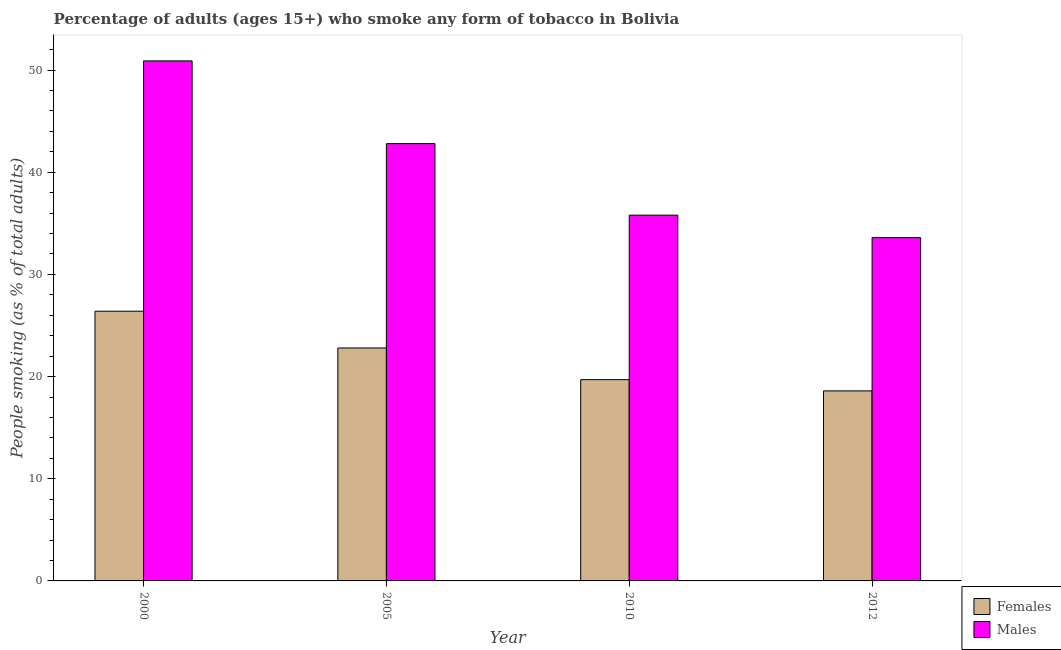How many groups of bars are there?
Your response must be concise. 4. Are the number of bars per tick equal to the number of legend labels?
Make the answer very short. Yes. In how many cases, is the number of bars for a given year not equal to the number of legend labels?
Provide a short and direct response. 0. What is the percentage of males who smoke in 2005?
Offer a very short reply. 42.8. Across all years, what is the maximum percentage of females who smoke?
Provide a short and direct response. 26.4. Across all years, what is the minimum percentage of males who smoke?
Offer a very short reply. 33.6. In which year was the percentage of males who smoke maximum?
Provide a succinct answer. 2000. In which year was the percentage of males who smoke minimum?
Your response must be concise. 2012. What is the total percentage of females who smoke in the graph?
Provide a succinct answer. 87.5. What is the difference between the percentage of males who smoke in 2010 and the percentage of females who smoke in 2000?
Provide a short and direct response. -15.1. What is the average percentage of males who smoke per year?
Offer a terse response. 40.77. What is the ratio of the percentage of females who smoke in 2005 to that in 2010?
Give a very brief answer. 1.16. Is the difference between the percentage of females who smoke in 2005 and 2010 greater than the difference between the percentage of males who smoke in 2005 and 2010?
Your answer should be compact. No. What is the difference between the highest and the second highest percentage of females who smoke?
Ensure brevity in your answer.  3.6. What is the difference between the highest and the lowest percentage of females who smoke?
Provide a short and direct response. 7.8. Is the sum of the percentage of females who smoke in 2000 and 2012 greater than the maximum percentage of males who smoke across all years?
Keep it short and to the point. Yes. What does the 2nd bar from the left in 2000 represents?
Your answer should be very brief. Males. What does the 2nd bar from the right in 2000 represents?
Make the answer very short. Females. How many bars are there?
Provide a succinct answer. 8. Are all the bars in the graph horizontal?
Give a very brief answer. No. Are the values on the major ticks of Y-axis written in scientific E-notation?
Make the answer very short. No. Does the graph contain any zero values?
Ensure brevity in your answer.  No. Where does the legend appear in the graph?
Keep it short and to the point. Bottom right. How many legend labels are there?
Keep it short and to the point. 2. How are the legend labels stacked?
Provide a short and direct response. Vertical. What is the title of the graph?
Provide a succinct answer. Percentage of adults (ages 15+) who smoke any form of tobacco in Bolivia. Does "Girls" appear as one of the legend labels in the graph?
Your answer should be compact. No. What is the label or title of the Y-axis?
Offer a terse response. People smoking (as % of total adults). What is the People smoking (as % of total adults) of Females in 2000?
Keep it short and to the point. 26.4. What is the People smoking (as % of total adults) in Males in 2000?
Your response must be concise. 50.9. What is the People smoking (as % of total adults) in Females in 2005?
Provide a short and direct response. 22.8. What is the People smoking (as % of total adults) in Males in 2005?
Provide a short and direct response. 42.8. What is the People smoking (as % of total adults) in Females in 2010?
Your answer should be very brief. 19.7. What is the People smoking (as % of total adults) of Males in 2010?
Offer a terse response. 35.8. What is the People smoking (as % of total adults) in Females in 2012?
Keep it short and to the point. 18.6. What is the People smoking (as % of total adults) in Males in 2012?
Offer a very short reply. 33.6. Across all years, what is the maximum People smoking (as % of total adults) in Females?
Your answer should be compact. 26.4. Across all years, what is the maximum People smoking (as % of total adults) in Males?
Ensure brevity in your answer.  50.9. Across all years, what is the minimum People smoking (as % of total adults) in Males?
Provide a succinct answer. 33.6. What is the total People smoking (as % of total adults) of Females in the graph?
Your response must be concise. 87.5. What is the total People smoking (as % of total adults) of Males in the graph?
Ensure brevity in your answer.  163.1. What is the difference between the People smoking (as % of total adults) of Females in 2000 and that in 2005?
Offer a very short reply. 3.6. What is the difference between the People smoking (as % of total adults) of Males in 2000 and that in 2005?
Provide a succinct answer. 8.1. What is the difference between the People smoking (as % of total adults) of Males in 2000 and that in 2010?
Keep it short and to the point. 15.1. What is the difference between the People smoking (as % of total adults) of Females in 2000 and the People smoking (as % of total adults) of Males in 2005?
Your response must be concise. -16.4. What is the average People smoking (as % of total adults) of Females per year?
Make the answer very short. 21.88. What is the average People smoking (as % of total adults) in Males per year?
Provide a short and direct response. 40.77. In the year 2000, what is the difference between the People smoking (as % of total adults) of Females and People smoking (as % of total adults) of Males?
Provide a succinct answer. -24.5. In the year 2005, what is the difference between the People smoking (as % of total adults) in Females and People smoking (as % of total adults) in Males?
Your answer should be compact. -20. In the year 2010, what is the difference between the People smoking (as % of total adults) of Females and People smoking (as % of total adults) of Males?
Provide a short and direct response. -16.1. In the year 2012, what is the difference between the People smoking (as % of total adults) of Females and People smoking (as % of total adults) of Males?
Your response must be concise. -15. What is the ratio of the People smoking (as % of total adults) in Females in 2000 to that in 2005?
Provide a succinct answer. 1.16. What is the ratio of the People smoking (as % of total adults) in Males in 2000 to that in 2005?
Offer a terse response. 1.19. What is the ratio of the People smoking (as % of total adults) of Females in 2000 to that in 2010?
Provide a succinct answer. 1.34. What is the ratio of the People smoking (as % of total adults) in Males in 2000 to that in 2010?
Give a very brief answer. 1.42. What is the ratio of the People smoking (as % of total adults) of Females in 2000 to that in 2012?
Your response must be concise. 1.42. What is the ratio of the People smoking (as % of total adults) in Males in 2000 to that in 2012?
Your answer should be compact. 1.51. What is the ratio of the People smoking (as % of total adults) in Females in 2005 to that in 2010?
Your response must be concise. 1.16. What is the ratio of the People smoking (as % of total adults) of Males in 2005 to that in 2010?
Provide a short and direct response. 1.2. What is the ratio of the People smoking (as % of total adults) in Females in 2005 to that in 2012?
Give a very brief answer. 1.23. What is the ratio of the People smoking (as % of total adults) in Males in 2005 to that in 2012?
Provide a short and direct response. 1.27. What is the ratio of the People smoking (as % of total adults) in Females in 2010 to that in 2012?
Offer a very short reply. 1.06. What is the ratio of the People smoking (as % of total adults) in Males in 2010 to that in 2012?
Keep it short and to the point. 1.07. What is the difference between the highest and the second highest People smoking (as % of total adults) in Males?
Provide a succinct answer. 8.1. 